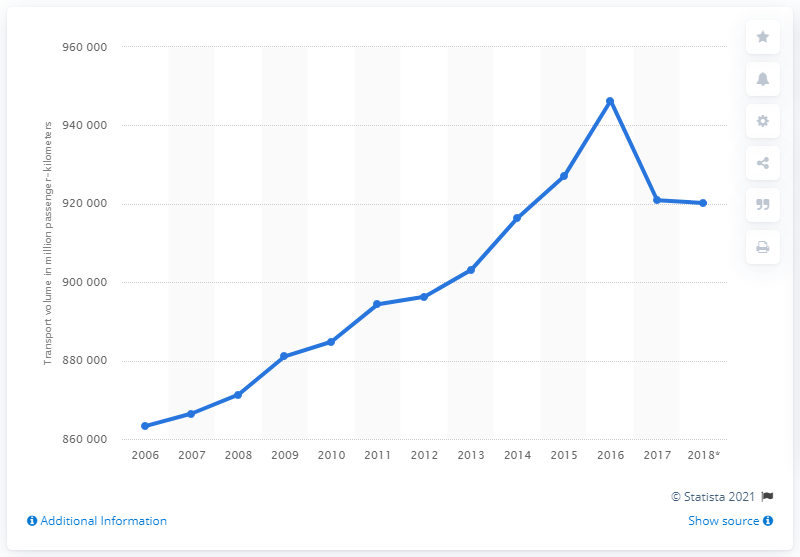Indicate a few pertinent items in this graphic. In 2018, passenger volume dropped to approximately 920,200 passenger-kilometers. 